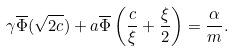Convert formula to latex. <formula><loc_0><loc_0><loc_500><loc_500>\gamma \overline { \Phi } ( \sqrt { 2 c } ) + a \overline { \Phi } \left ( \frac { c } { \xi } + \frac { \xi } { 2 } \right ) = \frac { \alpha } { m } .</formula> 